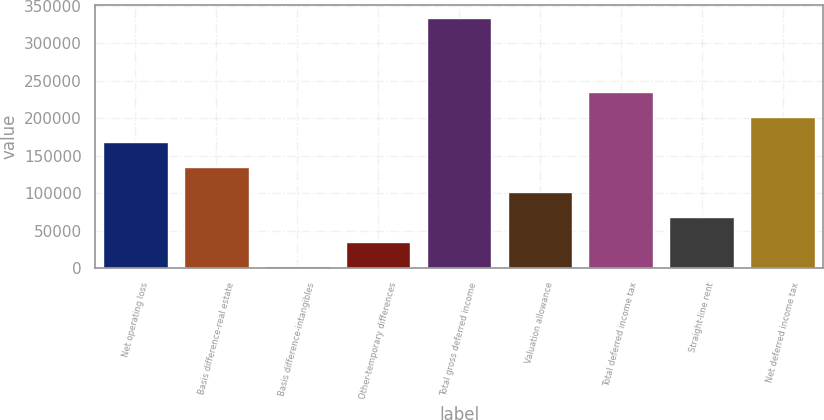<chart> <loc_0><loc_0><loc_500><loc_500><bar_chart><fcel>Net operating loss<fcel>Basis difference-real estate<fcel>Basis difference-intangibles<fcel>Other-temporary differences<fcel>Total gross deferred income<fcel>Valuation allowance<fcel>Total deferred income tax<fcel>Straight-line rent<fcel>Net deferred income tax<nl><fcel>168110<fcel>134888<fcel>2002<fcel>35223.6<fcel>334218<fcel>101667<fcel>234553<fcel>68445.2<fcel>201332<nl></chart> 